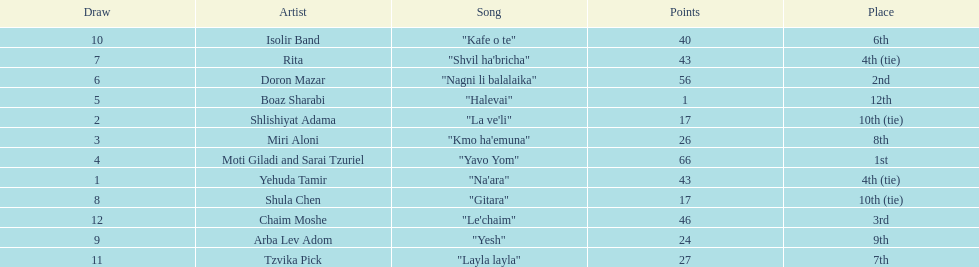How many points does the artist rita have? 43. 